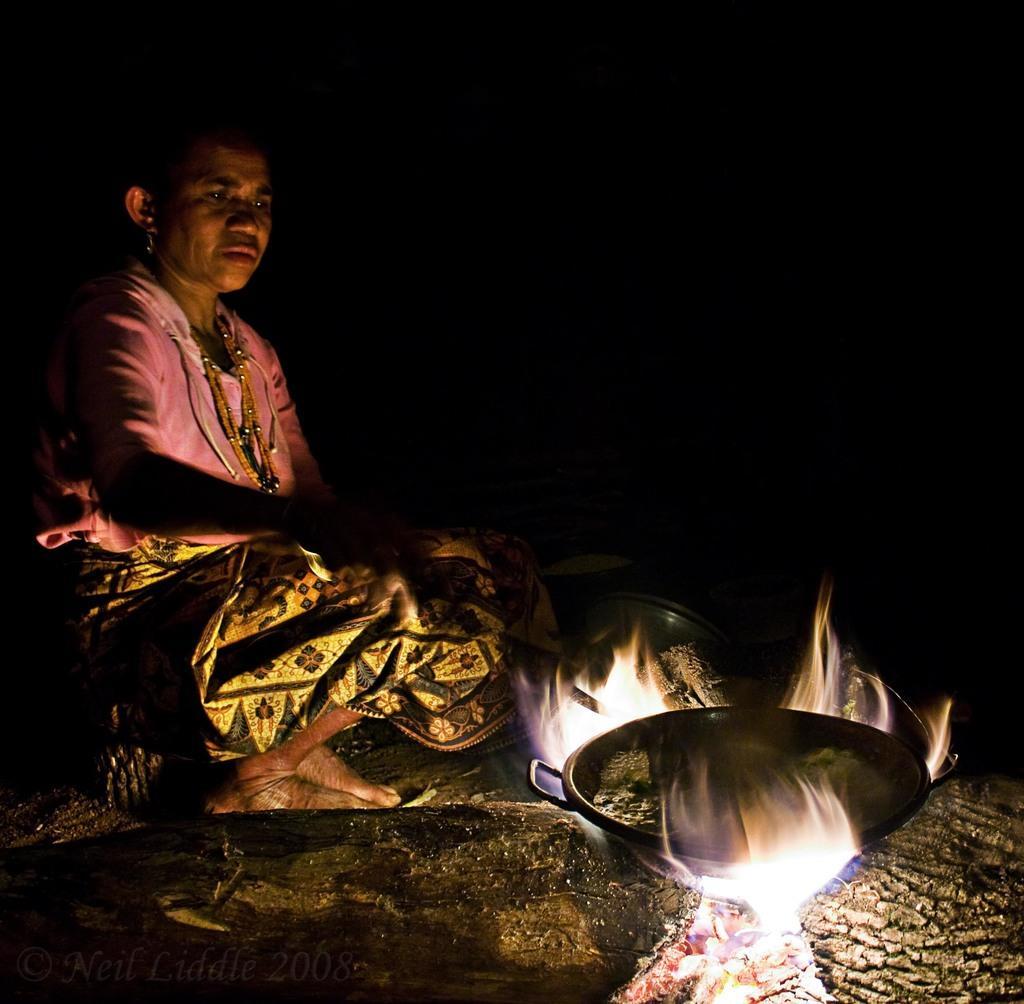How would you summarize this image in a sentence or two? In the bottom right corner of the image there is fire, on the fire there is a bowl. In the middle of the image a woman is sitting and holding a spoon. 